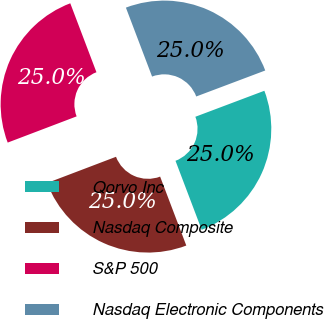Convert chart. <chart><loc_0><loc_0><loc_500><loc_500><pie_chart><fcel>Qorvo Inc<fcel>Nasdaq Composite<fcel>S&P 500<fcel>Nasdaq Electronic Components<nl><fcel>24.96%<fcel>24.99%<fcel>25.01%<fcel>25.04%<nl></chart> 